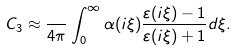<formula> <loc_0><loc_0><loc_500><loc_500>C _ { 3 } \approx \frac { } { 4 \pi } \int _ { 0 } ^ { \infty } \alpha ( i \xi ) \frac { \varepsilon ( i \xi ) - 1 } { \varepsilon ( i \xi ) + 1 } d \xi .</formula> 